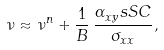<formula> <loc_0><loc_0><loc_500><loc_500>\nu \approx \nu ^ { n } + \frac { 1 } { B } \, \frac { \alpha _ { x y } ^ { \ } s S C } { \sigma _ { x x } } ,</formula> 